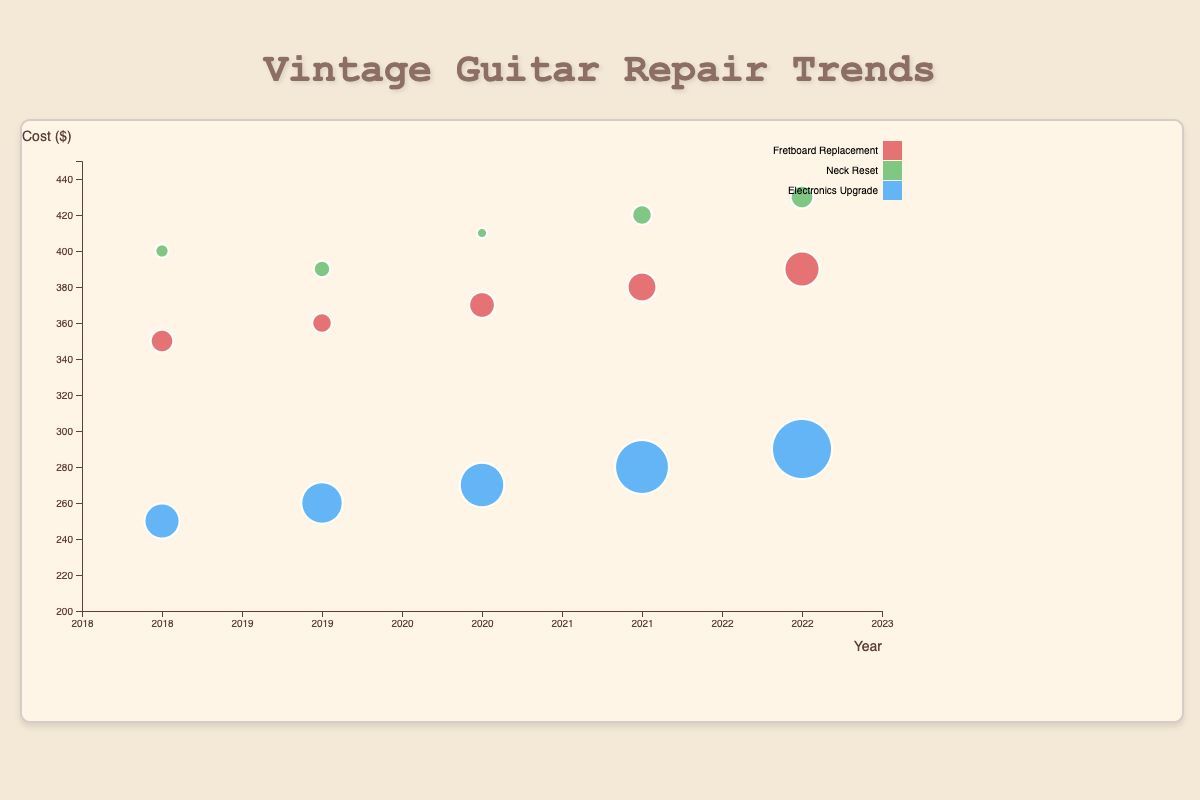What type of guitar repair had the highest frequency in 2019? Look at the size of the circles (frequency) for the year 2019. The largest circle belongs to "Electronics Upgrade".
Answer: Electronics Upgrade Which year had the highest cost for a Neck Reset? Compare the y-axis positions (cost) of the circles representing Neck Reset across all years. The highest y-position corresponds to the year 2022.
Answer: 2022 By how much did the frequency of Fretboard Replacement repairs increase from 2018 to 2022? Look at the bubble sizes for Fretboard Replacement in 2018 and 2022. The frequency in 2018 is 8 and in 2022 is 12. The increase is 12 - 8.
Answer: 4 Which repair type has the lowest cost across all years and what is that cost? Check the smallest y-axis positions for all repair types. The smallest cost is for "Electronics Upgrade" in 2018 with a cost of $250.
Answer: Electronics Upgrade, $250 Are there more Electronics Upgrade or Neck Reset repairs in 2021? Compare the sizes of bubbles for 2021 representing Electronics Upgrade and Neck Reset. The bubble for Electronics Upgrade is larger (frequency 18) compared to Neck Reset (frequency 7).
Answer: Electronics Upgrade What is the trend in the cost of Fretboard Replacement repairs from 2018 to 2022? Observe the vertical positions (cost) of Fretboard Replacement bubbles from 2018 to 2022. The costs are 350, 360, 370, 380, and 390 respectively. They show an increasing trend.
Answer: Increasing How does the frequency of Electronics Upgrade repairs in 2022 compare to 2018? Compare the sizes of the bubbles for Electronics Upgrade in 2022 and 2018. In 2022, the frequency is 20, and in 2018, it is 12.
Answer: Higher in 2022 Which repair type had the highest frequency in 2020, and what was the cost associated with it? Look for the largest bubble in the year 2020 and note its type and y-axis position. The largest is for "Electronics Upgrade" with a frequency of 15 and cost $270.
Answer: Electronics Upgrade, $270 What can be inferred from the size and color pattern for the year 2021? Examine the bubble sizes and colors for 2021. Electronics Upgrade has the highest frequency with blue color, followed by Fretboard Replacement with red, and Neck Reset with green.
Answer: Electronics Upgrade is most frequent, Fretboard Replacement next, least is Neck Reset What is the average cost of Neck Reset repairs over the years 2018 to 2022? Add the costs of Neck Reset for all years: 400 + 390 + 410 + 420 + 430 = 2050. Then divide by the number of years (5): 2050/5.
Answer: $410 